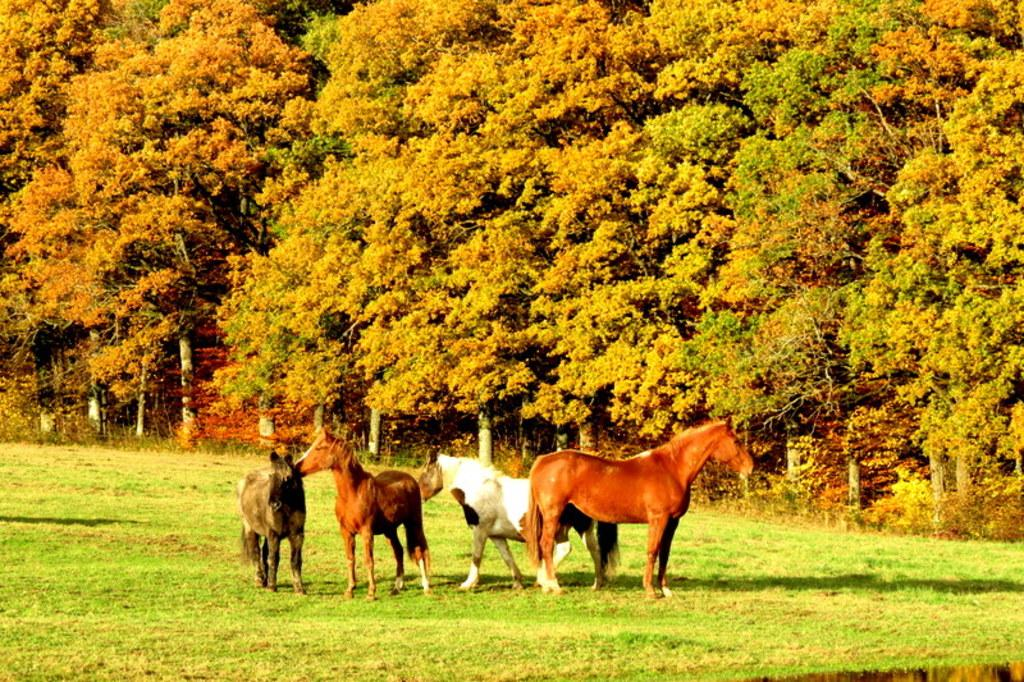What animals are present in the image? There are horses in the image. What can be seen in the background of the image? There are trees in the background of the image. What type of unit is being measured by the horses' toes in the image? There is no mention of any unit or measurement in the image, and horses do not have toes. 